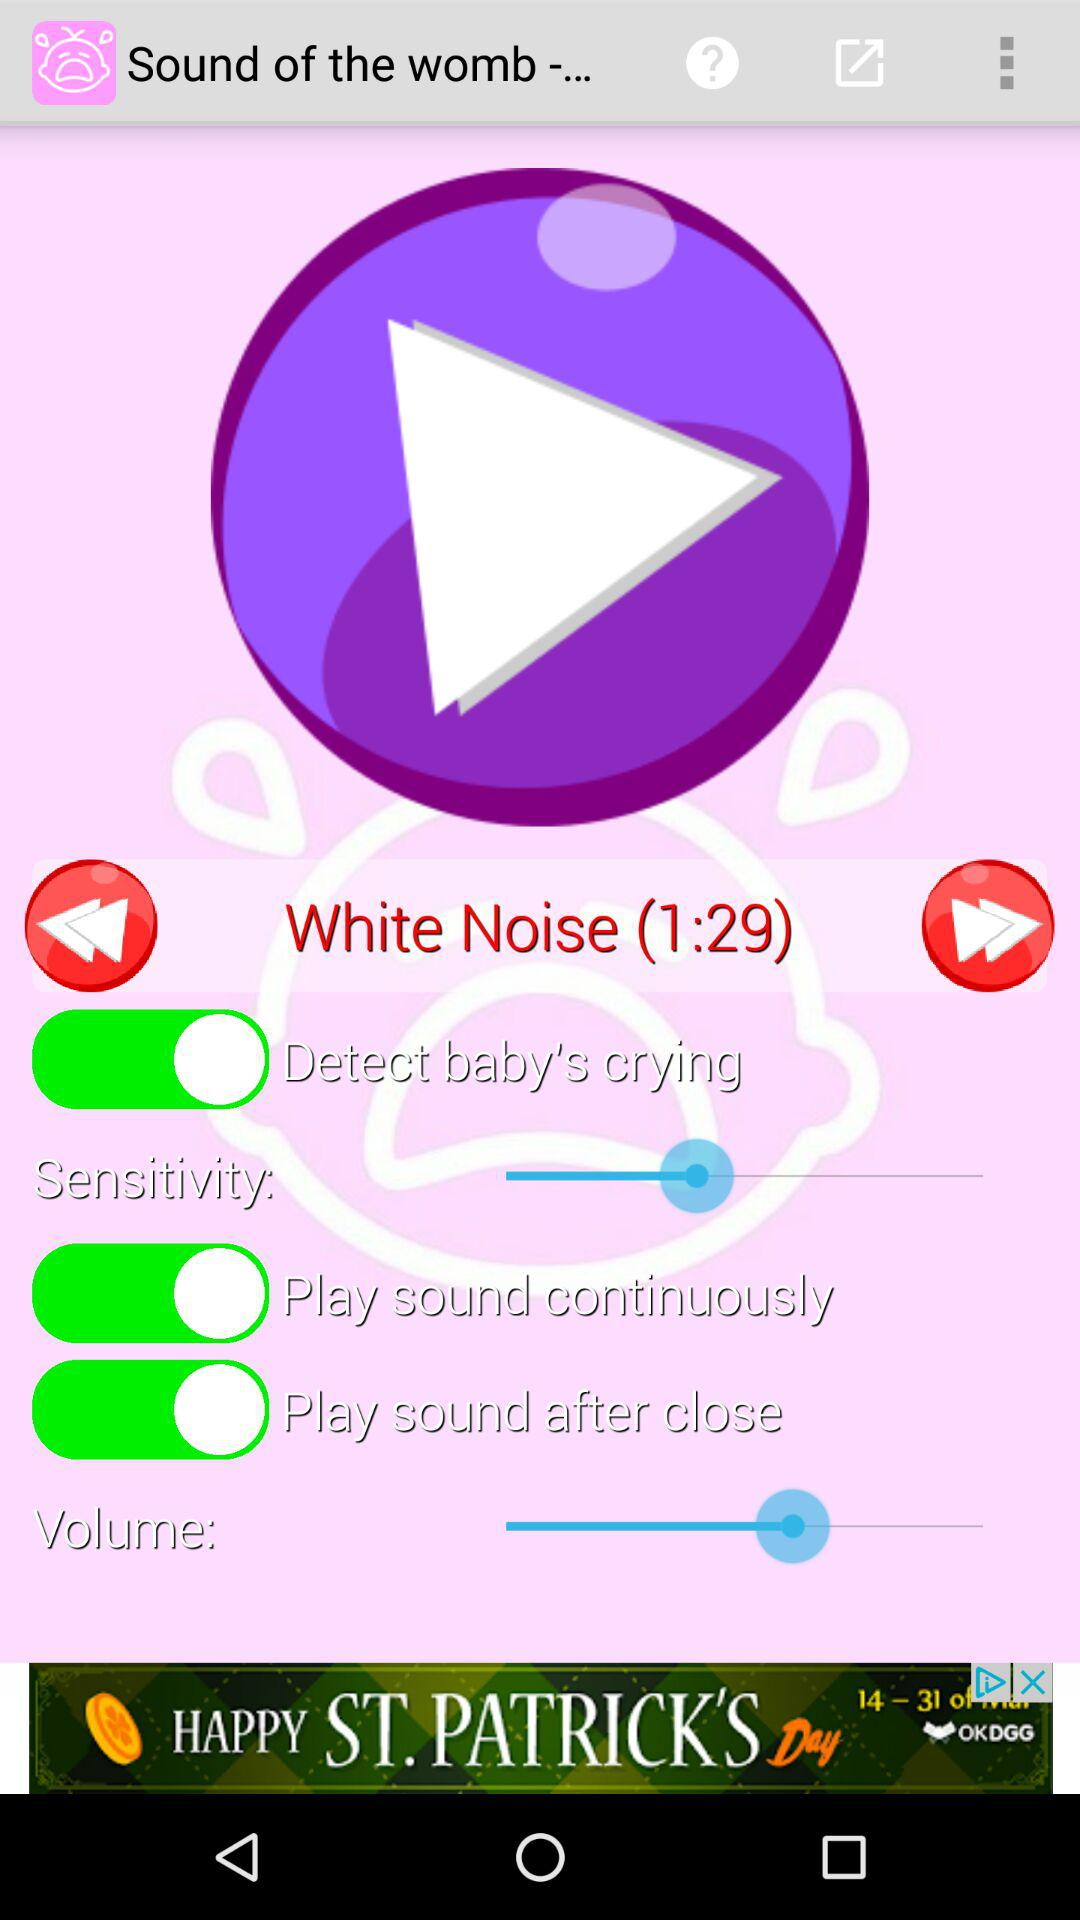What is the duration of "White Noise" music? The duration of "White Noise" music is 1 minute 29 seconds. 